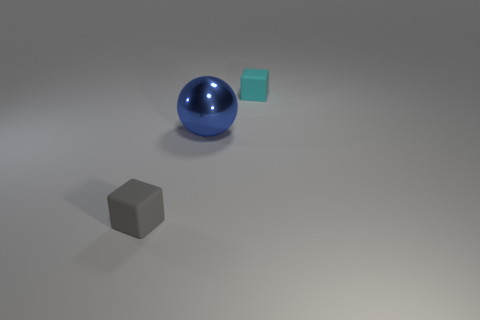Add 3 cyan balls. How many objects exist? 6 Subtract all blocks. How many objects are left? 1 Add 1 small gray rubber things. How many small gray rubber things are left? 2 Add 1 cyan blocks. How many cyan blocks exist? 2 Subtract 0 yellow cubes. How many objects are left? 3 Subtract all gray rubber cubes. Subtract all matte cylinders. How many objects are left? 2 